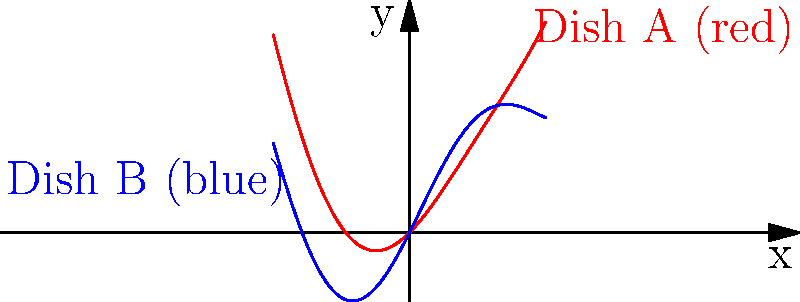In the culinary world, fractal patterns are often used to create visually stunning dishes. The graph above represents the plating techniques for two high-end dishes, A and B, where the x-axis represents the radial distance from the center of the plate, and the y-axis represents the height of the food elements. Given that Dish A follows the function $f(x) = 0.5x^2 + \sin(x)$ and Dish B follows $g(x) = 0.25x^2 + 2\sin(x)$, at what point do these two plating techniques intersect to create a harmonious visual balance? To find the intersection point of the two plating techniques, we need to solve the equation:

$$f(x) = g(x)$$

Substituting the given functions:

$$0.5x^2 + \sin(x) = 0.25x^2 + 2\sin(x)$$

Simplifying:

$$0.25x^2 - \sin(x) = 0$$

This equation cannot be solved algebraically due to the presence of both polynomial and trigonometric terms. However, we can observe from the graph that the intersection occurs near the origin.

Using numerical methods or graphing software, we can determine that the first positive intersection point is approximately:

$$x \approx 0.876$$

Substituting this value back into either function:

$$f(0.876) \approx g(0.876) \approx 0.384$$

Therefore, the plating techniques intersect at the point (0.876, 0.384), rounded to three decimal places.

This intersection represents a point where both dishes have the same height and radial distance from the center, creating a visual harmony between the two plating styles.
Answer: (0.876, 0.384) 